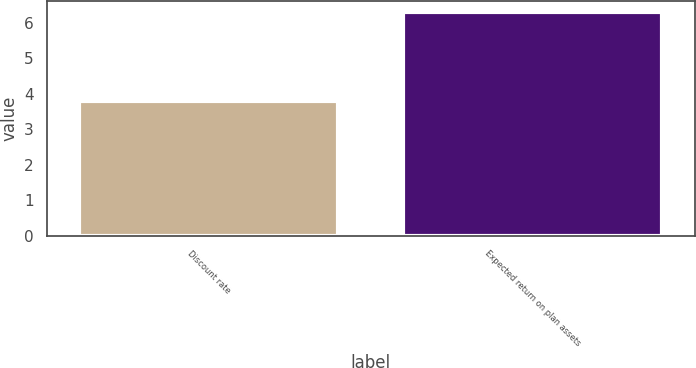<chart> <loc_0><loc_0><loc_500><loc_500><bar_chart><fcel>Discount rate<fcel>Expected return on plan assets<nl><fcel>3.8<fcel>6.3<nl></chart> 